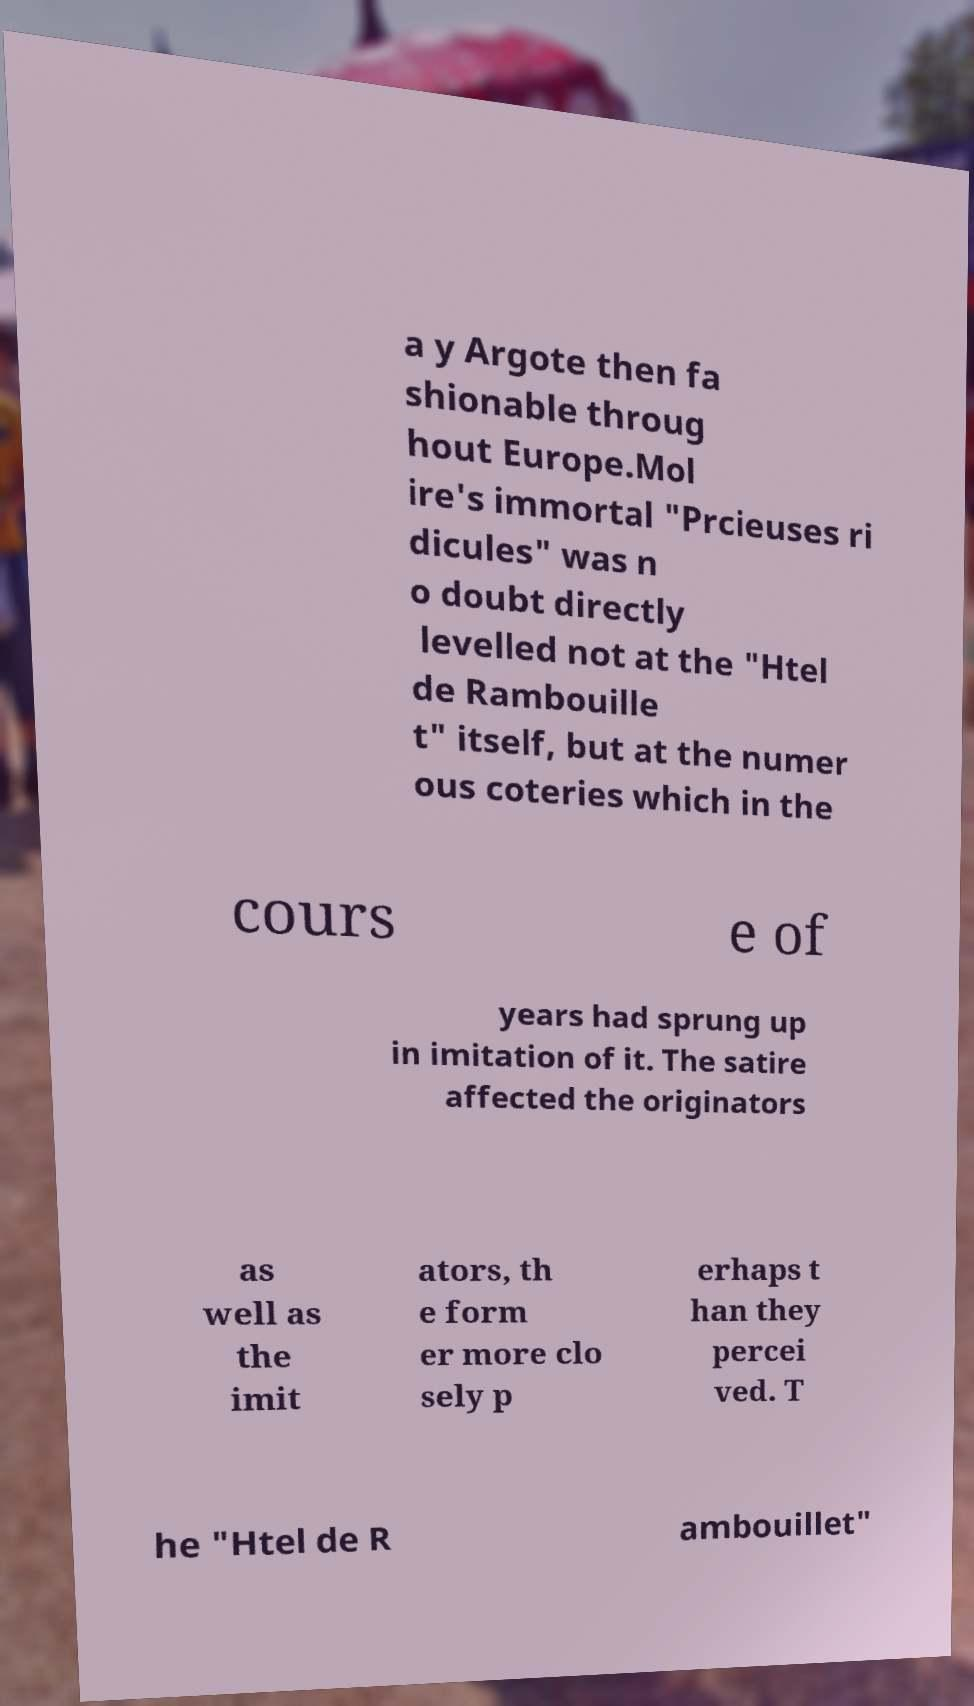I need the written content from this picture converted into text. Can you do that? a y Argote then fa shionable throug hout Europe.Mol ire's immortal "Prcieuses ri dicules" was n o doubt directly levelled not at the "Htel de Rambouille t" itself, but at the numer ous coteries which in the cours e of years had sprung up in imitation of it. The satire affected the originators as well as the imit ators, th e form er more clo sely p erhaps t han they percei ved. T he "Htel de R ambouillet" 